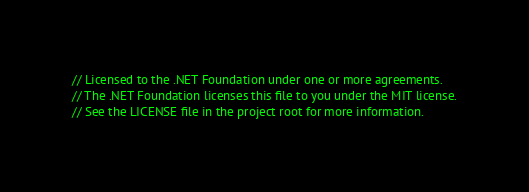<code> <loc_0><loc_0><loc_500><loc_500><_C#_>// Licensed to the .NET Foundation under one or more agreements.
// The .NET Foundation licenses this file to you under the MIT license.
// See the LICENSE file in the project root for more information.
</code> 